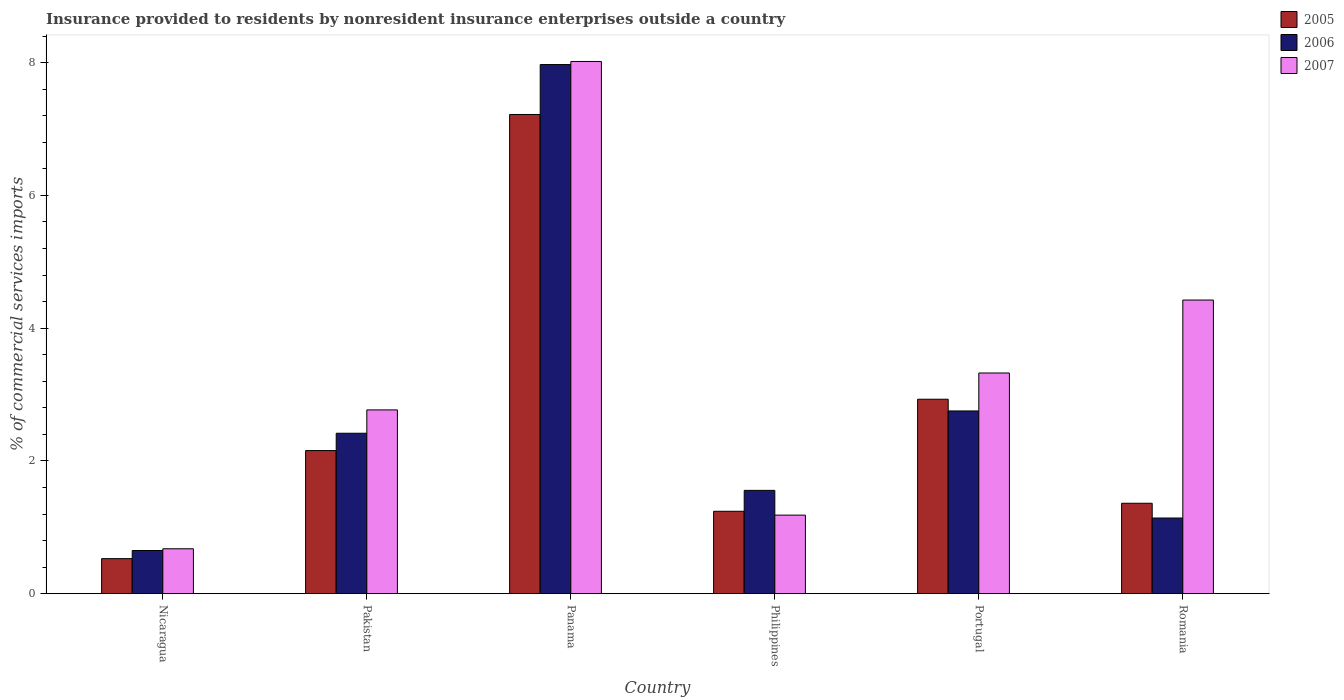How many bars are there on the 3rd tick from the left?
Provide a short and direct response. 3. How many bars are there on the 3rd tick from the right?
Give a very brief answer. 3. What is the label of the 5th group of bars from the left?
Give a very brief answer. Portugal. In how many cases, is the number of bars for a given country not equal to the number of legend labels?
Your answer should be very brief. 0. What is the Insurance provided to residents in 2007 in Nicaragua?
Provide a short and direct response. 0.68. Across all countries, what is the maximum Insurance provided to residents in 2005?
Your answer should be very brief. 7.22. Across all countries, what is the minimum Insurance provided to residents in 2007?
Give a very brief answer. 0.68. In which country was the Insurance provided to residents in 2005 maximum?
Your response must be concise. Panama. In which country was the Insurance provided to residents in 2007 minimum?
Your response must be concise. Nicaragua. What is the total Insurance provided to residents in 2007 in the graph?
Give a very brief answer. 20.39. What is the difference between the Insurance provided to residents in 2006 in Panama and that in Romania?
Ensure brevity in your answer.  6.83. What is the difference between the Insurance provided to residents in 2005 in Nicaragua and the Insurance provided to residents in 2006 in Romania?
Your answer should be very brief. -0.61. What is the average Insurance provided to residents in 2005 per country?
Your answer should be compact. 2.57. What is the difference between the Insurance provided to residents of/in 2006 and Insurance provided to residents of/in 2007 in Pakistan?
Your answer should be compact. -0.35. In how many countries, is the Insurance provided to residents in 2007 greater than 3.2 %?
Your answer should be compact. 3. What is the ratio of the Insurance provided to residents in 2006 in Pakistan to that in Portugal?
Your response must be concise. 0.88. What is the difference between the highest and the second highest Insurance provided to residents in 2006?
Offer a very short reply. 0.34. What is the difference between the highest and the lowest Insurance provided to residents in 2005?
Provide a succinct answer. 6.69. In how many countries, is the Insurance provided to residents in 2006 greater than the average Insurance provided to residents in 2006 taken over all countries?
Keep it short and to the point. 2. What is the difference between two consecutive major ticks on the Y-axis?
Offer a very short reply. 2. Does the graph contain any zero values?
Give a very brief answer. No. Where does the legend appear in the graph?
Make the answer very short. Top right. How are the legend labels stacked?
Ensure brevity in your answer.  Vertical. What is the title of the graph?
Provide a short and direct response. Insurance provided to residents by nonresident insurance enterprises outside a country. Does "1998" appear as one of the legend labels in the graph?
Offer a very short reply. No. What is the label or title of the X-axis?
Give a very brief answer. Country. What is the label or title of the Y-axis?
Provide a succinct answer. % of commercial services imports. What is the % of commercial services imports in 2005 in Nicaragua?
Provide a short and direct response. 0.53. What is the % of commercial services imports of 2006 in Nicaragua?
Your answer should be very brief. 0.65. What is the % of commercial services imports in 2007 in Nicaragua?
Your answer should be very brief. 0.68. What is the % of commercial services imports in 2005 in Pakistan?
Your response must be concise. 2.16. What is the % of commercial services imports in 2006 in Pakistan?
Your response must be concise. 2.42. What is the % of commercial services imports of 2007 in Pakistan?
Ensure brevity in your answer.  2.77. What is the % of commercial services imports in 2005 in Panama?
Offer a terse response. 7.22. What is the % of commercial services imports in 2006 in Panama?
Offer a terse response. 7.97. What is the % of commercial services imports of 2007 in Panama?
Your answer should be compact. 8.02. What is the % of commercial services imports of 2005 in Philippines?
Make the answer very short. 1.24. What is the % of commercial services imports in 2006 in Philippines?
Offer a very short reply. 1.56. What is the % of commercial services imports in 2007 in Philippines?
Provide a succinct answer. 1.18. What is the % of commercial services imports of 2005 in Portugal?
Your answer should be compact. 2.93. What is the % of commercial services imports of 2006 in Portugal?
Your response must be concise. 2.75. What is the % of commercial services imports of 2007 in Portugal?
Provide a short and direct response. 3.32. What is the % of commercial services imports in 2005 in Romania?
Keep it short and to the point. 1.36. What is the % of commercial services imports of 2006 in Romania?
Give a very brief answer. 1.14. What is the % of commercial services imports of 2007 in Romania?
Offer a very short reply. 4.42. Across all countries, what is the maximum % of commercial services imports in 2005?
Keep it short and to the point. 7.22. Across all countries, what is the maximum % of commercial services imports of 2006?
Keep it short and to the point. 7.97. Across all countries, what is the maximum % of commercial services imports of 2007?
Offer a terse response. 8.02. Across all countries, what is the minimum % of commercial services imports in 2005?
Provide a short and direct response. 0.53. Across all countries, what is the minimum % of commercial services imports of 2006?
Your answer should be very brief. 0.65. Across all countries, what is the minimum % of commercial services imports of 2007?
Your answer should be very brief. 0.68. What is the total % of commercial services imports in 2005 in the graph?
Give a very brief answer. 15.43. What is the total % of commercial services imports of 2006 in the graph?
Your response must be concise. 16.48. What is the total % of commercial services imports of 2007 in the graph?
Your answer should be very brief. 20.39. What is the difference between the % of commercial services imports of 2005 in Nicaragua and that in Pakistan?
Your answer should be very brief. -1.63. What is the difference between the % of commercial services imports of 2006 in Nicaragua and that in Pakistan?
Your response must be concise. -1.77. What is the difference between the % of commercial services imports in 2007 in Nicaragua and that in Pakistan?
Your response must be concise. -2.09. What is the difference between the % of commercial services imports of 2005 in Nicaragua and that in Panama?
Your response must be concise. -6.69. What is the difference between the % of commercial services imports of 2006 in Nicaragua and that in Panama?
Offer a terse response. -7.32. What is the difference between the % of commercial services imports in 2007 in Nicaragua and that in Panama?
Provide a short and direct response. -7.34. What is the difference between the % of commercial services imports of 2005 in Nicaragua and that in Philippines?
Ensure brevity in your answer.  -0.71. What is the difference between the % of commercial services imports of 2006 in Nicaragua and that in Philippines?
Your answer should be very brief. -0.91. What is the difference between the % of commercial services imports of 2007 in Nicaragua and that in Philippines?
Your answer should be compact. -0.51. What is the difference between the % of commercial services imports of 2005 in Nicaragua and that in Portugal?
Provide a short and direct response. -2.4. What is the difference between the % of commercial services imports in 2006 in Nicaragua and that in Portugal?
Keep it short and to the point. -2.1. What is the difference between the % of commercial services imports in 2007 in Nicaragua and that in Portugal?
Your response must be concise. -2.65. What is the difference between the % of commercial services imports in 2005 in Nicaragua and that in Romania?
Ensure brevity in your answer.  -0.83. What is the difference between the % of commercial services imports of 2006 in Nicaragua and that in Romania?
Your answer should be very brief. -0.49. What is the difference between the % of commercial services imports in 2007 in Nicaragua and that in Romania?
Give a very brief answer. -3.75. What is the difference between the % of commercial services imports of 2005 in Pakistan and that in Panama?
Your answer should be very brief. -5.06. What is the difference between the % of commercial services imports of 2006 in Pakistan and that in Panama?
Give a very brief answer. -5.55. What is the difference between the % of commercial services imports of 2007 in Pakistan and that in Panama?
Provide a succinct answer. -5.25. What is the difference between the % of commercial services imports in 2005 in Pakistan and that in Philippines?
Provide a short and direct response. 0.91. What is the difference between the % of commercial services imports in 2006 in Pakistan and that in Philippines?
Your answer should be very brief. 0.86. What is the difference between the % of commercial services imports of 2007 in Pakistan and that in Philippines?
Your response must be concise. 1.59. What is the difference between the % of commercial services imports of 2005 in Pakistan and that in Portugal?
Provide a succinct answer. -0.77. What is the difference between the % of commercial services imports in 2006 in Pakistan and that in Portugal?
Your answer should be very brief. -0.34. What is the difference between the % of commercial services imports in 2007 in Pakistan and that in Portugal?
Offer a terse response. -0.56. What is the difference between the % of commercial services imports of 2005 in Pakistan and that in Romania?
Ensure brevity in your answer.  0.79. What is the difference between the % of commercial services imports in 2006 in Pakistan and that in Romania?
Offer a terse response. 1.28. What is the difference between the % of commercial services imports of 2007 in Pakistan and that in Romania?
Your answer should be very brief. -1.65. What is the difference between the % of commercial services imports in 2005 in Panama and that in Philippines?
Your response must be concise. 5.98. What is the difference between the % of commercial services imports of 2006 in Panama and that in Philippines?
Offer a terse response. 6.41. What is the difference between the % of commercial services imports of 2007 in Panama and that in Philippines?
Offer a very short reply. 6.83. What is the difference between the % of commercial services imports of 2005 in Panama and that in Portugal?
Your response must be concise. 4.29. What is the difference between the % of commercial services imports in 2006 in Panama and that in Portugal?
Provide a short and direct response. 5.22. What is the difference between the % of commercial services imports of 2007 in Panama and that in Portugal?
Offer a terse response. 4.69. What is the difference between the % of commercial services imports in 2005 in Panama and that in Romania?
Your answer should be compact. 5.86. What is the difference between the % of commercial services imports in 2006 in Panama and that in Romania?
Make the answer very short. 6.83. What is the difference between the % of commercial services imports of 2007 in Panama and that in Romania?
Provide a succinct answer. 3.59. What is the difference between the % of commercial services imports of 2005 in Philippines and that in Portugal?
Your answer should be very brief. -1.69. What is the difference between the % of commercial services imports in 2006 in Philippines and that in Portugal?
Offer a very short reply. -1.2. What is the difference between the % of commercial services imports in 2007 in Philippines and that in Portugal?
Offer a very short reply. -2.14. What is the difference between the % of commercial services imports of 2005 in Philippines and that in Romania?
Your answer should be very brief. -0.12. What is the difference between the % of commercial services imports in 2006 in Philippines and that in Romania?
Offer a very short reply. 0.42. What is the difference between the % of commercial services imports in 2007 in Philippines and that in Romania?
Provide a succinct answer. -3.24. What is the difference between the % of commercial services imports of 2005 in Portugal and that in Romania?
Offer a terse response. 1.57. What is the difference between the % of commercial services imports in 2006 in Portugal and that in Romania?
Your answer should be very brief. 1.61. What is the difference between the % of commercial services imports in 2007 in Portugal and that in Romania?
Provide a short and direct response. -1.1. What is the difference between the % of commercial services imports of 2005 in Nicaragua and the % of commercial services imports of 2006 in Pakistan?
Keep it short and to the point. -1.89. What is the difference between the % of commercial services imports in 2005 in Nicaragua and the % of commercial services imports in 2007 in Pakistan?
Your answer should be very brief. -2.24. What is the difference between the % of commercial services imports in 2006 in Nicaragua and the % of commercial services imports in 2007 in Pakistan?
Ensure brevity in your answer.  -2.12. What is the difference between the % of commercial services imports of 2005 in Nicaragua and the % of commercial services imports of 2006 in Panama?
Ensure brevity in your answer.  -7.44. What is the difference between the % of commercial services imports in 2005 in Nicaragua and the % of commercial services imports in 2007 in Panama?
Provide a short and direct response. -7.49. What is the difference between the % of commercial services imports in 2006 in Nicaragua and the % of commercial services imports in 2007 in Panama?
Provide a succinct answer. -7.37. What is the difference between the % of commercial services imports of 2005 in Nicaragua and the % of commercial services imports of 2006 in Philippines?
Ensure brevity in your answer.  -1.03. What is the difference between the % of commercial services imports of 2005 in Nicaragua and the % of commercial services imports of 2007 in Philippines?
Offer a very short reply. -0.66. What is the difference between the % of commercial services imports in 2006 in Nicaragua and the % of commercial services imports in 2007 in Philippines?
Your answer should be compact. -0.53. What is the difference between the % of commercial services imports in 2005 in Nicaragua and the % of commercial services imports in 2006 in Portugal?
Offer a terse response. -2.22. What is the difference between the % of commercial services imports of 2005 in Nicaragua and the % of commercial services imports of 2007 in Portugal?
Offer a terse response. -2.8. What is the difference between the % of commercial services imports in 2006 in Nicaragua and the % of commercial services imports in 2007 in Portugal?
Your response must be concise. -2.67. What is the difference between the % of commercial services imports in 2005 in Nicaragua and the % of commercial services imports in 2006 in Romania?
Make the answer very short. -0.61. What is the difference between the % of commercial services imports in 2005 in Nicaragua and the % of commercial services imports in 2007 in Romania?
Make the answer very short. -3.9. What is the difference between the % of commercial services imports of 2006 in Nicaragua and the % of commercial services imports of 2007 in Romania?
Keep it short and to the point. -3.77. What is the difference between the % of commercial services imports in 2005 in Pakistan and the % of commercial services imports in 2006 in Panama?
Give a very brief answer. -5.82. What is the difference between the % of commercial services imports of 2005 in Pakistan and the % of commercial services imports of 2007 in Panama?
Offer a terse response. -5.86. What is the difference between the % of commercial services imports in 2006 in Pakistan and the % of commercial services imports in 2007 in Panama?
Provide a short and direct response. -5.6. What is the difference between the % of commercial services imports of 2005 in Pakistan and the % of commercial services imports of 2006 in Philippines?
Your answer should be compact. 0.6. What is the difference between the % of commercial services imports of 2005 in Pakistan and the % of commercial services imports of 2007 in Philippines?
Provide a succinct answer. 0.97. What is the difference between the % of commercial services imports of 2006 in Pakistan and the % of commercial services imports of 2007 in Philippines?
Provide a succinct answer. 1.23. What is the difference between the % of commercial services imports of 2005 in Pakistan and the % of commercial services imports of 2006 in Portugal?
Provide a succinct answer. -0.6. What is the difference between the % of commercial services imports of 2005 in Pakistan and the % of commercial services imports of 2007 in Portugal?
Your answer should be compact. -1.17. What is the difference between the % of commercial services imports of 2006 in Pakistan and the % of commercial services imports of 2007 in Portugal?
Keep it short and to the point. -0.91. What is the difference between the % of commercial services imports in 2005 in Pakistan and the % of commercial services imports in 2006 in Romania?
Make the answer very short. 1.02. What is the difference between the % of commercial services imports of 2005 in Pakistan and the % of commercial services imports of 2007 in Romania?
Provide a succinct answer. -2.27. What is the difference between the % of commercial services imports in 2006 in Pakistan and the % of commercial services imports in 2007 in Romania?
Provide a succinct answer. -2.01. What is the difference between the % of commercial services imports of 2005 in Panama and the % of commercial services imports of 2006 in Philippines?
Make the answer very short. 5.66. What is the difference between the % of commercial services imports of 2005 in Panama and the % of commercial services imports of 2007 in Philippines?
Your response must be concise. 6.04. What is the difference between the % of commercial services imports in 2006 in Panama and the % of commercial services imports in 2007 in Philippines?
Provide a short and direct response. 6.79. What is the difference between the % of commercial services imports of 2005 in Panama and the % of commercial services imports of 2006 in Portugal?
Provide a short and direct response. 4.47. What is the difference between the % of commercial services imports in 2005 in Panama and the % of commercial services imports in 2007 in Portugal?
Provide a short and direct response. 3.89. What is the difference between the % of commercial services imports in 2006 in Panama and the % of commercial services imports in 2007 in Portugal?
Provide a succinct answer. 4.65. What is the difference between the % of commercial services imports of 2005 in Panama and the % of commercial services imports of 2006 in Romania?
Offer a very short reply. 6.08. What is the difference between the % of commercial services imports in 2005 in Panama and the % of commercial services imports in 2007 in Romania?
Give a very brief answer. 2.8. What is the difference between the % of commercial services imports of 2006 in Panama and the % of commercial services imports of 2007 in Romania?
Ensure brevity in your answer.  3.55. What is the difference between the % of commercial services imports of 2005 in Philippines and the % of commercial services imports of 2006 in Portugal?
Provide a succinct answer. -1.51. What is the difference between the % of commercial services imports in 2005 in Philippines and the % of commercial services imports in 2007 in Portugal?
Provide a succinct answer. -2.08. What is the difference between the % of commercial services imports in 2006 in Philippines and the % of commercial services imports in 2007 in Portugal?
Your response must be concise. -1.77. What is the difference between the % of commercial services imports of 2005 in Philippines and the % of commercial services imports of 2006 in Romania?
Your answer should be compact. 0.1. What is the difference between the % of commercial services imports of 2005 in Philippines and the % of commercial services imports of 2007 in Romania?
Offer a terse response. -3.18. What is the difference between the % of commercial services imports in 2006 in Philippines and the % of commercial services imports in 2007 in Romania?
Offer a terse response. -2.87. What is the difference between the % of commercial services imports of 2005 in Portugal and the % of commercial services imports of 2006 in Romania?
Ensure brevity in your answer.  1.79. What is the difference between the % of commercial services imports in 2005 in Portugal and the % of commercial services imports in 2007 in Romania?
Your answer should be compact. -1.49. What is the difference between the % of commercial services imports of 2006 in Portugal and the % of commercial services imports of 2007 in Romania?
Your answer should be compact. -1.67. What is the average % of commercial services imports in 2005 per country?
Your answer should be very brief. 2.57. What is the average % of commercial services imports of 2006 per country?
Your response must be concise. 2.75. What is the average % of commercial services imports in 2007 per country?
Offer a very short reply. 3.4. What is the difference between the % of commercial services imports of 2005 and % of commercial services imports of 2006 in Nicaragua?
Ensure brevity in your answer.  -0.12. What is the difference between the % of commercial services imports of 2005 and % of commercial services imports of 2007 in Nicaragua?
Provide a succinct answer. -0.15. What is the difference between the % of commercial services imports in 2006 and % of commercial services imports in 2007 in Nicaragua?
Your response must be concise. -0.03. What is the difference between the % of commercial services imports in 2005 and % of commercial services imports in 2006 in Pakistan?
Your answer should be compact. -0.26. What is the difference between the % of commercial services imports in 2005 and % of commercial services imports in 2007 in Pakistan?
Your response must be concise. -0.61. What is the difference between the % of commercial services imports in 2006 and % of commercial services imports in 2007 in Pakistan?
Keep it short and to the point. -0.35. What is the difference between the % of commercial services imports of 2005 and % of commercial services imports of 2006 in Panama?
Provide a short and direct response. -0.75. What is the difference between the % of commercial services imports in 2005 and % of commercial services imports in 2007 in Panama?
Keep it short and to the point. -0.8. What is the difference between the % of commercial services imports in 2006 and % of commercial services imports in 2007 in Panama?
Your response must be concise. -0.05. What is the difference between the % of commercial services imports in 2005 and % of commercial services imports in 2006 in Philippines?
Offer a very short reply. -0.31. What is the difference between the % of commercial services imports of 2005 and % of commercial services imports of 2007 in Philippines?
Give a very brief answer. 0.06. What is the difference between the % of commercial services imports of 2006 and % of commercial services imports of 2007 in Philippines?
Offer a terse response. 0.37. What is the difference between the % of commercial services imports of 2005 and % of commercial services imports of 2006 in Portugal?
Offer a very short reply. 0.18. What is the difference between the % of commercial services imports in 2005 and % of commercial services imports in 2007 in Portugal?
Give a very brief answer. -0.4. What is the difference between the % of commercial services imports in 2006 and % of commercial services imports in 2007 in Portugal?
Provide a succinct answer. -0.57. What is the difference between the % of commercial services imports in 2005 and % of commercial services imports in 2006 in Romania?
Your answer should be very brief. 0.22. What is the difference between the % of commercial services imports of 2005 and % of commercial services imports of 2007 in Romania?
Give a very brief answer. -3.06. What is the difference between the % of commercial services imports in 2006 and % of commercial services imports in 2007 in Romania?
Your response must be concise. -3.28. What is the ratio of the % of commercial services imports in 2005 in Nicaragua to that in Pakistan?
Make the answer very short. 0.24. What is the ratio of the % of commercial services imports of 2006 in Nicaragua to that in Pakistan?
Offer a very short reply. 0.27. What is the ratio of the % of commercial services imports in 2007 in Nicaragua to that in Pakistan?
Make the answer very short. 0.24. What is the ratio of the % of commercial services imports in 2005 in Nicaragua to that in Panama?
Make the answer very short. 0.07. What is the ratio of the % of commercial services imports in 2006 in Nicaragua to that in Panama?
Your answer should be compact. 0.08. What is the ratio of the % of commercial services imports of 2007 in Nicaragua to that in Panama?
Your answer should be compact. 0.08. What is the ratio of the % of commercial services imports in 2005 in Nicaragua to that in Philippines?
Offer a terse response. 0.43. What is the ratio of the % of commercial services imports in 2006 in Nicaragua to that in Philippines?
Ensure brevity in your answer.  0.42. What is the ratio of the % of commercial services imports of 2005 in Nicaragua to that in Portugal?
Make the answer very short. 0.18. What is the ratio of the % of commercial services imports of 2006 in Nicaragua to that in Portugal?
Offer a very short reply. 0.24. What is the ratio of the % of commercial services imports in 2007 in Nicaragua to that in Portugal?
Provide a succinct answer. 0.2. What is the ratio of the % of commercial services imports of 2005 in Nicaragua to that in Romania?
Your answer should be very brief. 0.39. What is the ratio of the % of commercial services imports of 2006 in Nicaragua to that in Romania?
Your response must be concise. 0.57. What is the ratio of the % of commercial services imports of 2007 in Nicaragua to that in Romania?
Provide a succinct answer. 0.15. What is the ratio of the % of commercial services imports of 2005 in Pakistan to that in Panama?
Your response must be concise. 0.3. What is the ratio of the % of commercial services imports of 2006 in Pakistan to that in Panama?
Ensure brevity in your answer.  0.3. What is the ratio of the % of commercial services imports of 2007 in Pakistan to that in Panama?
Your answer should be compact. 0.35. What is the ratio of the % of commercial services imports in 2005 in Pakistan to that in Philippines?
Make the answer very short. 1.74. What is the ratio of the % of commercial services imports in 2006 in Pakistan to that in Philippines?
Make the answer very short. 1.55. What is the ratio of the % of commercial services imports in 2007 in Pakistan to that in Philippines?
Provide a short and direct response. 2.34. What is the ratio of the % of commercial services imports of 2005 in Pakistan to that in Portugal?
Ensure brevity in your answer.  0.74. What is the ratio of the % of commercial services imports in 2006 in Pakistan to that in Portugal?
Your answer should be very brief. 0.88. What is the ratio of the % of commercial services imports in 2007 in Pakistan to that in Portugal?
Provide a succinct answer. 0.83. What is the ratio of the % of commercial services imports in 2005 in Pakistan to that in Romania?
Provide a short and direct response. 1.58. What is the ratio of the % of commercial services imports in 2006 in Pakistan to that in Romania?
Ensure brevity in your answer.  2.12. What is the ratio of the % of commercial services imports in 2007 in Pakistan to that in Romania?
Give a very brief answer. 0.63. What is the ratio of the % of commercial services imports in 2005 in Panama to that in Philippines?
Provide a short and direct response. 5.82. What is the ratio of the % of commercial services imports in 2006 in Panama to that in Philippines?
Provide a succinct answer. 5.12. What is the ratio of the % of commercial services imports of 2007 in Panama to that in Philippines?
Your response must be concise. 6.78. What is the ratio of the % of commercial services imports in 2005 in Panama to that in Portugal?
Provide a succinct answer. 2.46. What is the ratio of the % of commercial services imports in 2006 in Panama to that in Portugal?
Your response must be concise. 2.9. What is the ratio of the % of commercial services imports in 2007 in Panama to that in Portugal?
Offer a terse response. 2.41. What is the ratio of the % of commercial services imports of 2005 in Panama to that in Romania?
Provide a short and direct response. 5.3. What is the ratio of the % of commercial services imports in 2006 in Panama to that in Romania?
Offer a very short reply. 7. What is the ratio of the % of commercial services imports in 2007 in Panama to that in Romania?
Give a very brief answer. 1.81. What is the ratio of the % of commercial services imports of 2005 in Philippines to that in Portugal?
Your answer should be compact. 0.42. What is the ratio of the % of commercial services imports in 2006 in Philippines to that in Portugal?
Your response must be concise. 0.57. What is the ratio of the % of commercial services imports in 2007 in Philippines to that in Portugal?
Give a very brief answer. 0.36. What is the ratio of the % of commercial services imports of 2005 in Philippines to that in Romania?
Offer a very short reply. 0.91. What is the ratio of the % of commercial services imports in 2006 in Philippines to that in Romania?
Your answer should be very brief. 1.37. What is the ratio of the % of commercial services imports of 2007 in Philippines to that in Romania?
Offer a terse response. 0.27. What is the ratio of the % of commercial services imports of 2005 in Portugal to that in Romania?
Keep it short and to the point. 2.15. What is the ratio of the % of commercial services imports in 2006 in Portugal to that in Romania?
Your answer should be very brief. 2.42. What is the ratio of the % of commercial services imports in 2007 in Portugal to that in Romania?
Your response must be concise. 0.75. What is the difference between the highest and the second highest % of commercial services imports in 2005?
Provide a short and direct response. 4.29. What is the difference between the highest and the second highest % of commercial services imports in 2006?
Make the answer very short. 5.22. What is the difference between the highest and the second highest % of commercial services imports of 2007?
Your answer should be very brief. 3.59. What is the difference between the highest and the lowest % of commercial services imports of 2005?
Offer a terse response. 6.69. What is the difference between the highest and the lowest % of commercial services imports of 2006?
Your response must be concise. 7.32. What is the difference between the highest and the lowest % of commercial services imports in 2007?
Provide a short and direct response. 7.34. 